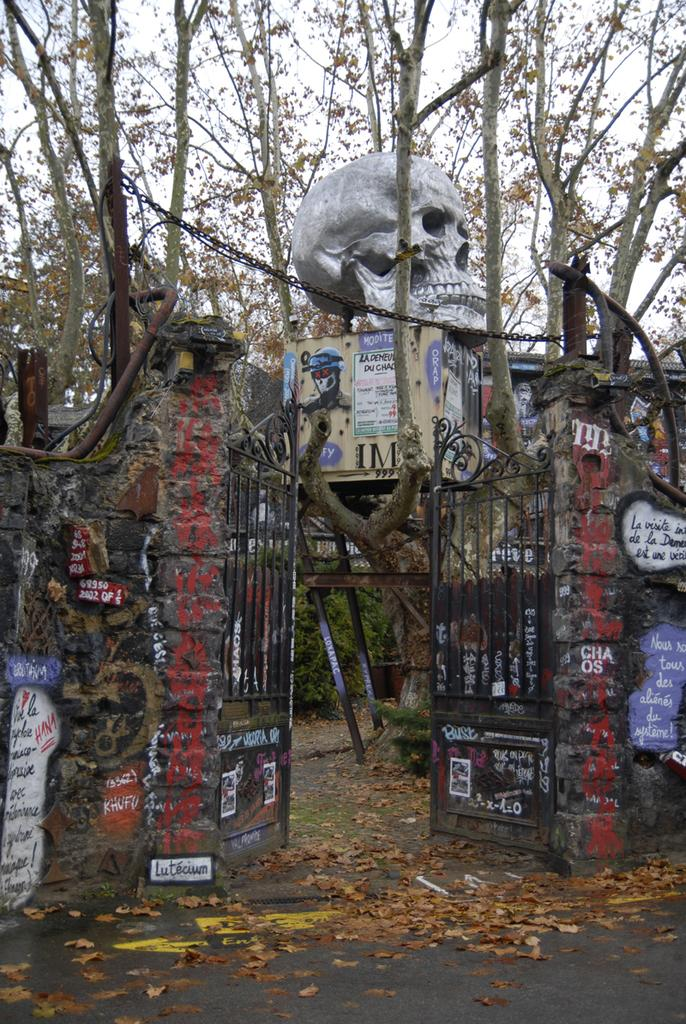What is the main structure in the center of the image? There is a gate in the center of the image. What can be seen at the top side of the image? There is a skull at the top side of the image. What type of natural environment is visible in the background of the image? There are trees in the background of the image. What type of chairs can be seen in the image? There are no chairs present in the image. How does the behavior of the skull in the image affect the overall mood of the scene? The image does not depict any behavior or mood, as it is a still image. 